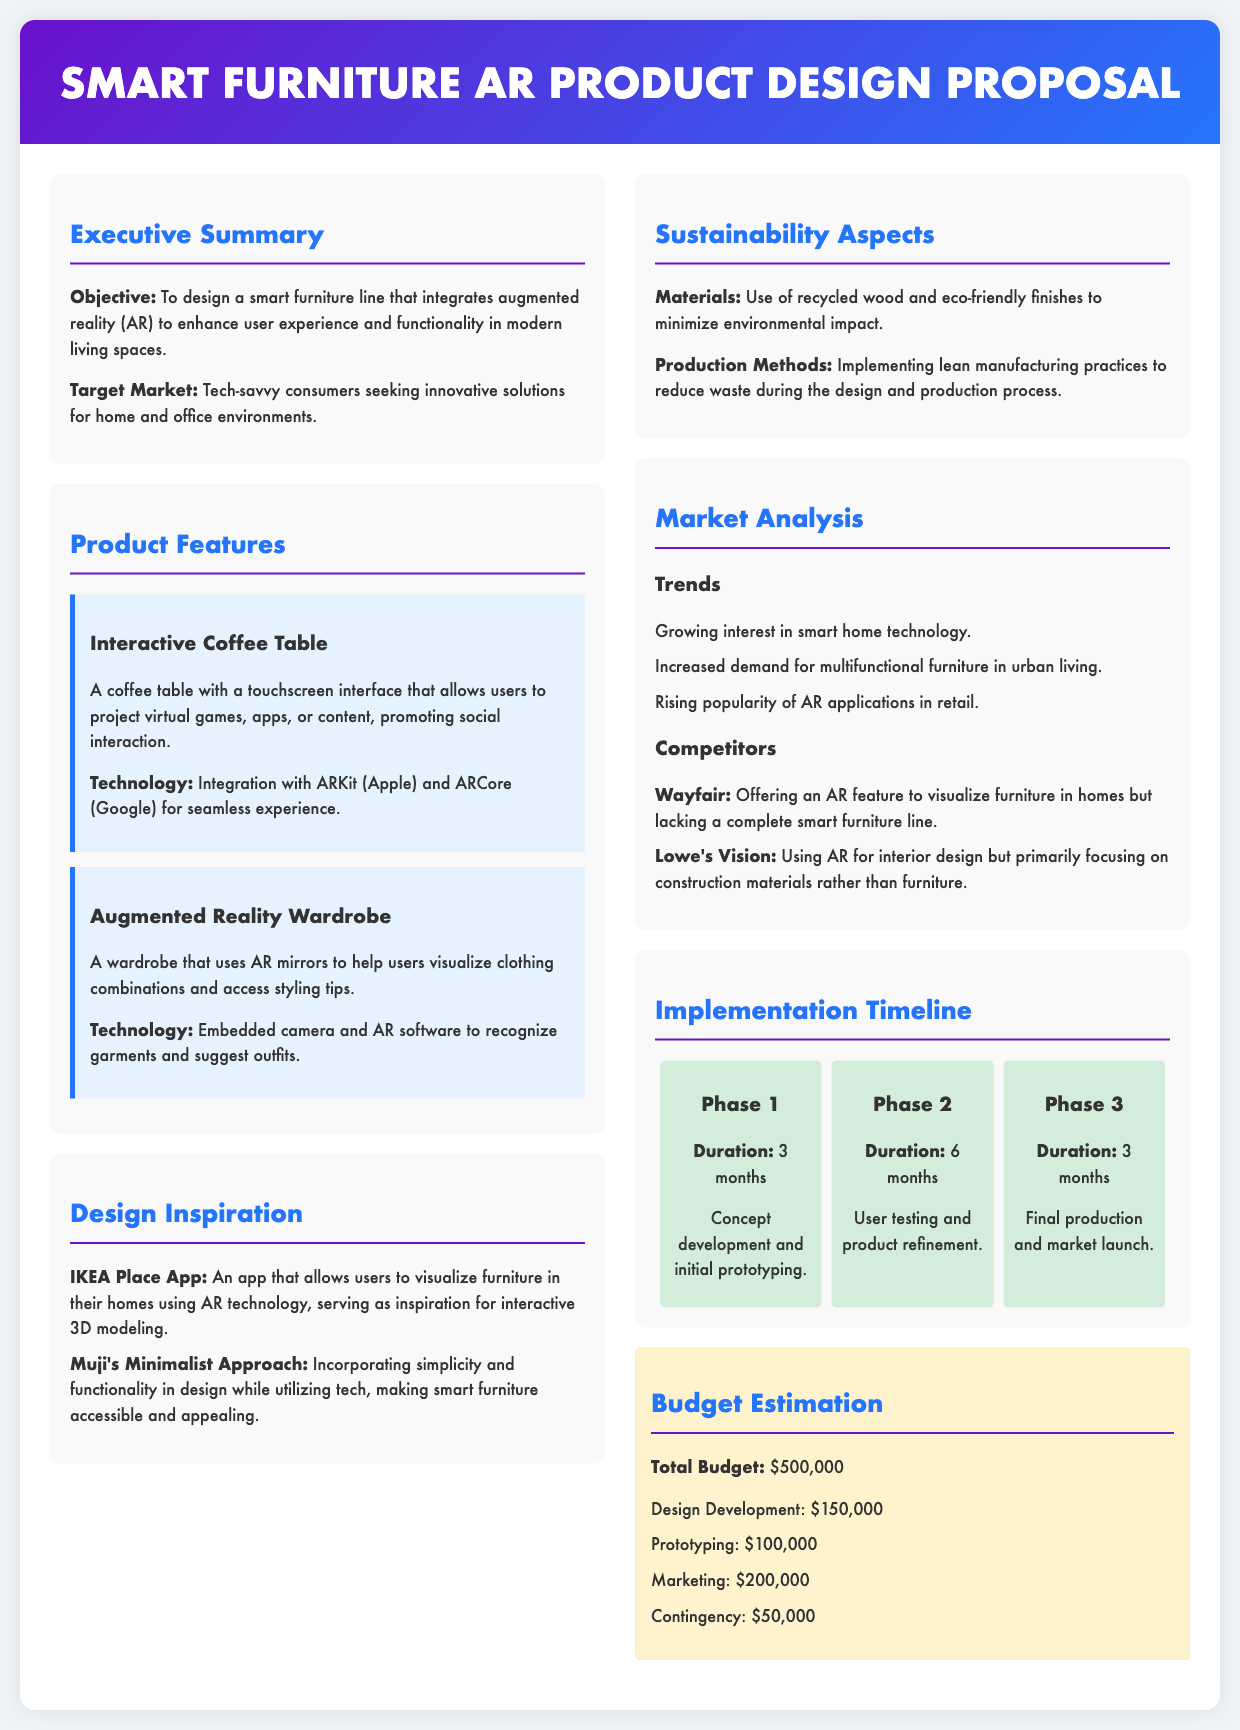What is the objective of the proposal? The objective is to design a smart furniture line that integrates augmented reality to enhance user experience and functionality in modern living spaces.
Answer: To design a smart furniture line that integrates augmented reality to enhance user experience and functionality in modern living spaces Who is the target market? The target market is defined in the document as tech-savvy consumers seeking innovative solutions for home and office environments.
Answer: Tech-savvy consumers seeking innovative solutions for home and office environments What is the total budget for the project? The total budget for the project is specified in the budget estimation section of the document.
Answer: $500,000 How long is Phase 2 of the project? Phase 2 duration is mentioned in the implementation timeline, which details the different phases and their lengths.
Answer: 6 months What technology is used in the Augmented Reality Wardrobe? The technology used is mentioned along with the description of the wardrobe's capabilities in the product features section.
Answer: Embedded camera and AR software What sustainable materials are mentioned in the sustainability aspects? The sustainability aspects section provides specific information regarding the materials used in the smart furniture line.
Answer: Recycled wood Which app served as inspiration for the design? The design inspiration section lists specific examples that influenced the design concepts in the proposal.
Answer: IKEA Place App What are the competitors listed in the market analysis? The market analysis section identifies key competitors in the market for smart furniture.
Answer: Wayfair, Lowe's Vision What production method is aimed at reducing waste? The document mentions specific production methods in the sustainability aspects that contribute to reducing environmental impact.
Answer: Lean manufacturing practices 